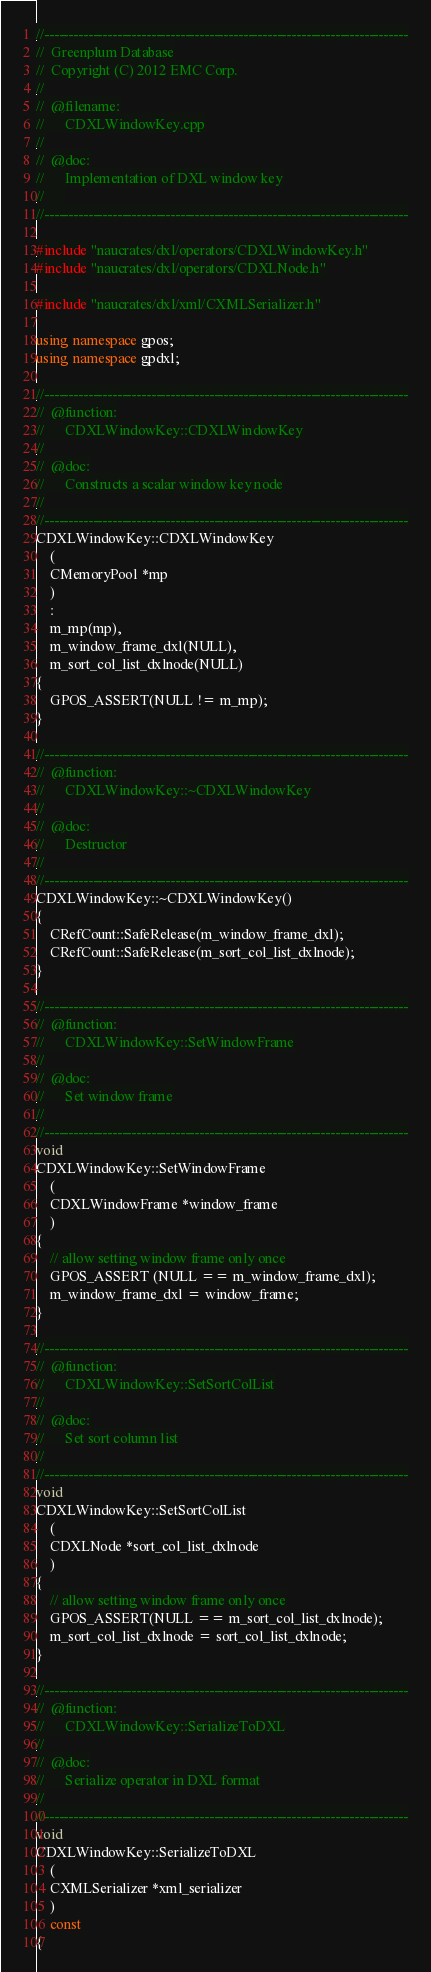Convert code to text. <code><loc_0><loc_0><loc_500><loc_500><_C++_>//---------------------------------------------------------------------------
//	Greenplum Database
//	Copyright (C) 2012 EMC Corp.
//
//	@filename:
//		CDXLWindowKey.cpp
//
//	@doc:
//		Implementation of DXL window key
//		
//---------------------------------------------------------------------------

#include "naucrates/dxl/operators/CDXLWindowKey.h"
#include "naucrates/dxl/operators/CDXLNode.h"

#include "naucrates/dxl/xml/CXMLSerializer.h"

using namespace gpos;
using namespace gpdxl;

//---------------------------------------------------------------------------
//	@function:
//		CDXLWindowKey::CDXLWindowKey
//
//	@doc:
//		Constructs a scalar window key node
//
//---------------------------------------------------------------------------
CDXLWindowKey::CDXLWindowKey
	(
	CMemoryPool *mp
	)
	:
	m_mp(mp),
	m_window_frame_dxl(NULL),
	m_sort_col_list_dxlnode(NULL)
{
	GPOS_ASSERT(NULL != m_mp);
}

//---------------------------------------------------------------------------
//	@function:
//		CDXLWindowKey::~CDXLWindowKey
//
//	@doc:
//		Destructor
//
//---------------------------------------------------------------------------
CDXLWindowKey::~CDXLWindowKey()
{
	CRefCount::SafeRelease(m_window_frame_dxl);
	CRefCount::SafeRelease(m_sort_col_list_dxlnode);
}

//---------------------------------------------------------------------------
//	@function:
//		CDXLWindowKey::SetWindowFrame
//
//	@doc:
//		Set window frame
//
//---------------------------------------------------------------------------
void
CDXLWindowKey::SetWindowFrame
	(
	CDXLWindowFrame *window_frame
	)
{
	// allow setting window frame only once
	GPOS_ASSERT (NULL == m_window_frame_dxl);
	m_window_frame_dxl = window_frame;
}

//---------------------------------------------------------------------------
//	@function:
//		CDXLWindowKey::SetSortColList
//
//	@doc:
//		Set sort column list
//
//---------------------------------------------------------------------------
void
CDXLWindowKey::SetSortColList
	(
	CDXLNode *sort_col_list_dxlnode
	)
{
	// allow setting window frame only once
	GPOS_ASSERT(NULL == m_sort_col_list_dxlnode);
	m_sort_col_list_dxlnode = sort_col_list_dxlnode;
}

//---------------------------------------------------------------------------
//	@function:
//		CDXLWindowKey::SerializeToDXL
//
//	@doc:
//		Serialize operator in DXL format
//
//---------------------------------------------------------------------------
void
CDXLWindowKey::SerializeToDXL
	(
	CXMLSerializer *xml_serializer
	)
	const
{</code> 